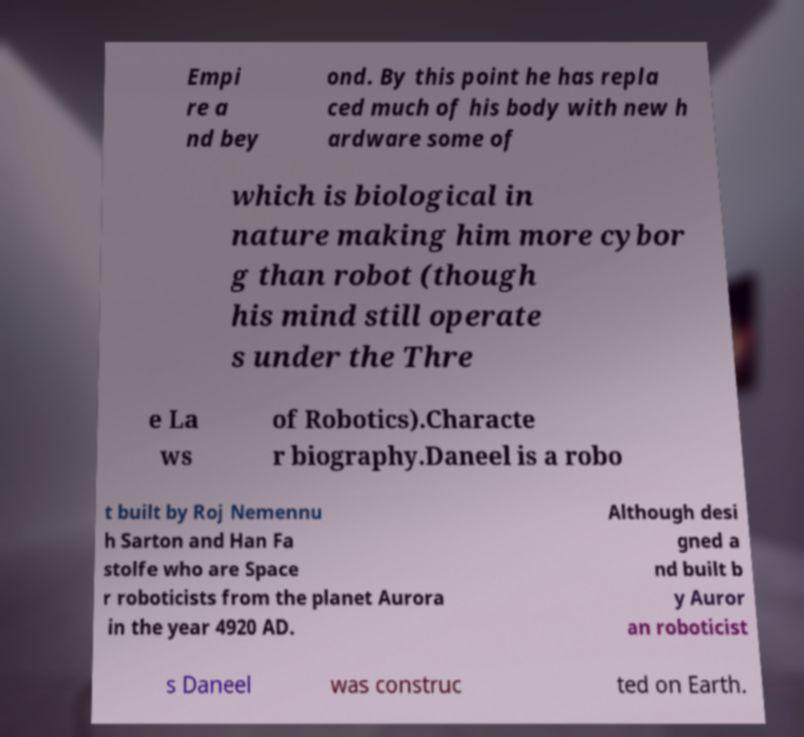Could you assist in decoding the text presented in this image and type it out clearly? Empi re a nd bey ond. By this point he has repla ced much of his body with new h ardware some of which is biological in nature making him more cybor g than robot (though his mind still operate s under the Thre e La ws of Robotics).Characte r biography.Daneel is a robo t built by Roj Nemennu h Sarton and Han Fa stolfe who are Space r roboticists from the planet Aurora in the year 4920 AD. Although desi gned a nd built b y Auror an roboticist s Daneel was construc ted on Earth. 